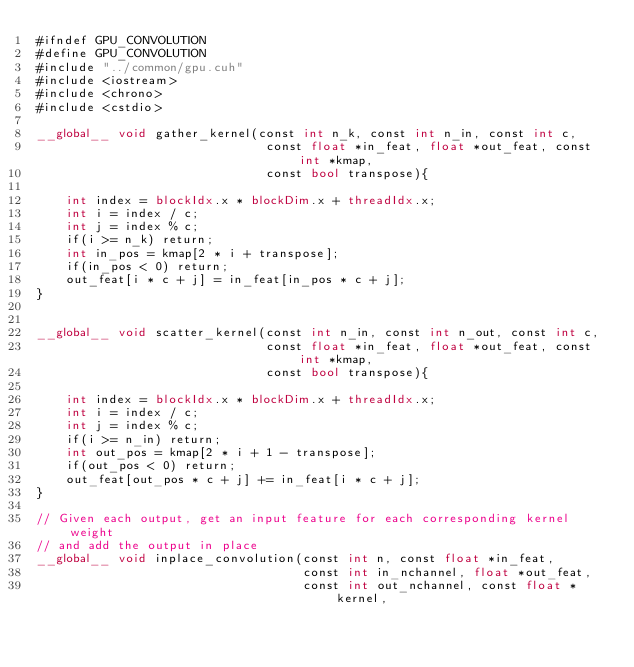<code> <loc_0><loc_0><loc_500><loc_500><_Cuda_>#ifndef GPU_CONVOLUTION
#define GPU_CONVOLUTION
#include "../common/gpu.cuh"
#include <iostream>
#include <chrono>
#include <cstdio>

__global__ void gather_kernel(const int n_k, const int n_in, const int c, 
                               const float *in_feat, float *out_feat, const int *kmap,
                               const bool transpose){

    int index = blockIdx.x * blockDim.x + threadIdx.x;
    int i = index / c;
    int j = index % c;
    if(i >= n_k) return;
    int in_pos = kmap[2 * i + transpose];
    if(in_pos < 0) return;
    out_feat[i * c + j] = in_feat[in_pos * c + j];
}


__global__ void scatter_kernel(const int n_in, const int n_out, const int c, 
                               const float *in_feat, float *out_feat, const int *kmap,
                               const bool transpose){

    int index = blockIdx.x * blockDim.x + threadIdx.x;
    int i = index / c;
    int j = index % c;
    if(i >= n_in) return;
    int out_pos = kmap[2 * i + 1 - transpose];
    if(out_pos < 0) return;
    out_feat[out_pos * c + j] += in_feat[i * c + j];
}

// Given each output, get an input feature for each corresponding kernel weight
// and add the output in place
__global__ void inplace_convolution(const int n, const float *in_feat,
                                    const int in_nchannel, float *out_feat,
                                    const int out_nchannel, const float *kernel,</code> 